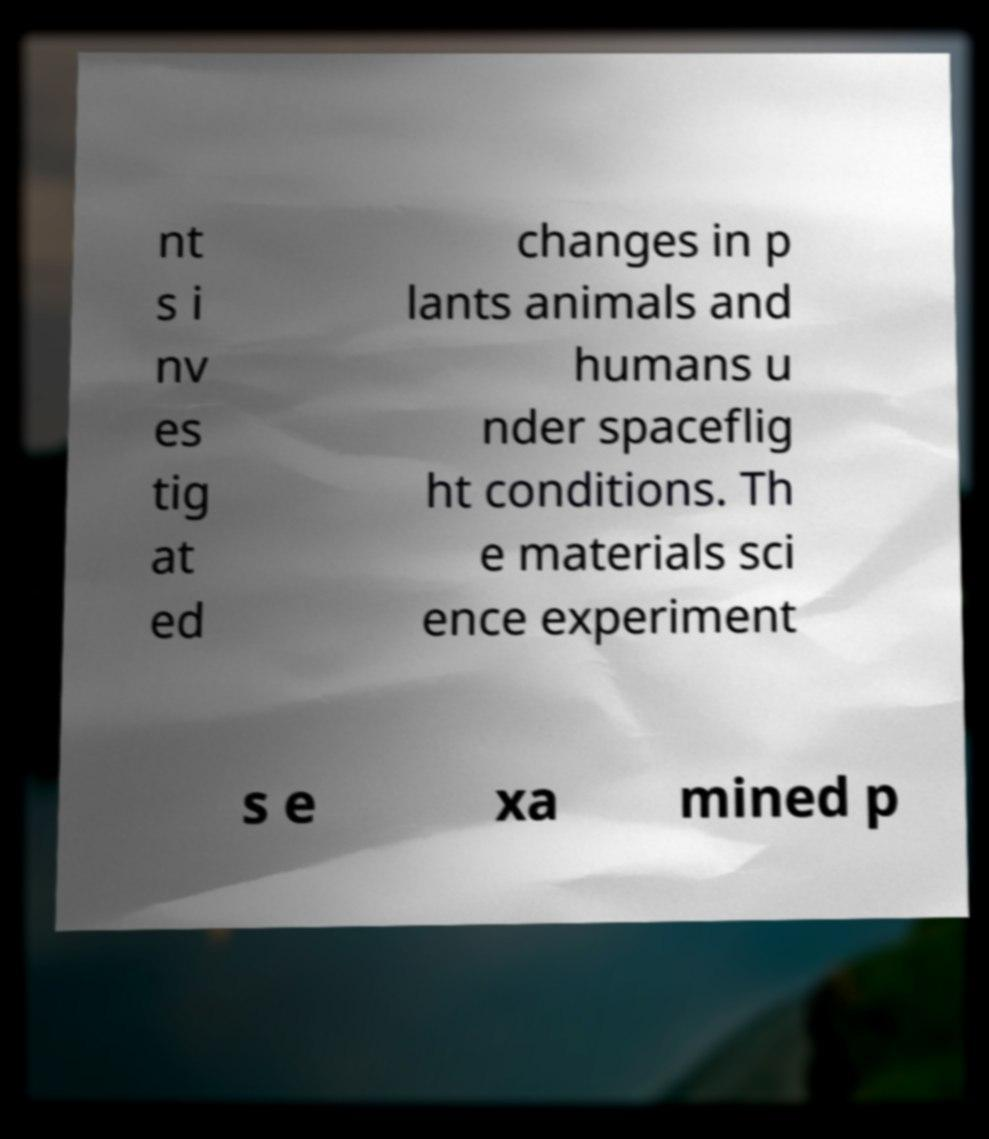Could you assist in decoding the text presented in this image and type it out clearly? nt s i nv es tig at ed changes in p lants animals and humans u nder spaceflig ht conditions. Th e materials sci ence experiment s e xa mined p 